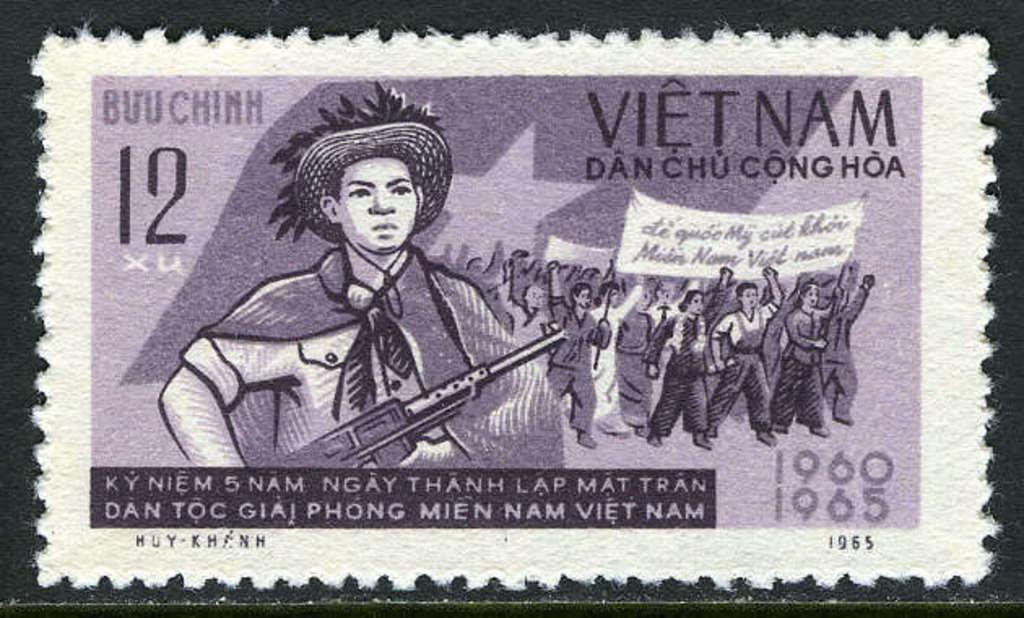Describe this image in one or two sentences. In this image we can see a postage stamp. On postage stamp we can see a group of people and they are holding some banner in their hands. There is some text written on the stamp. 